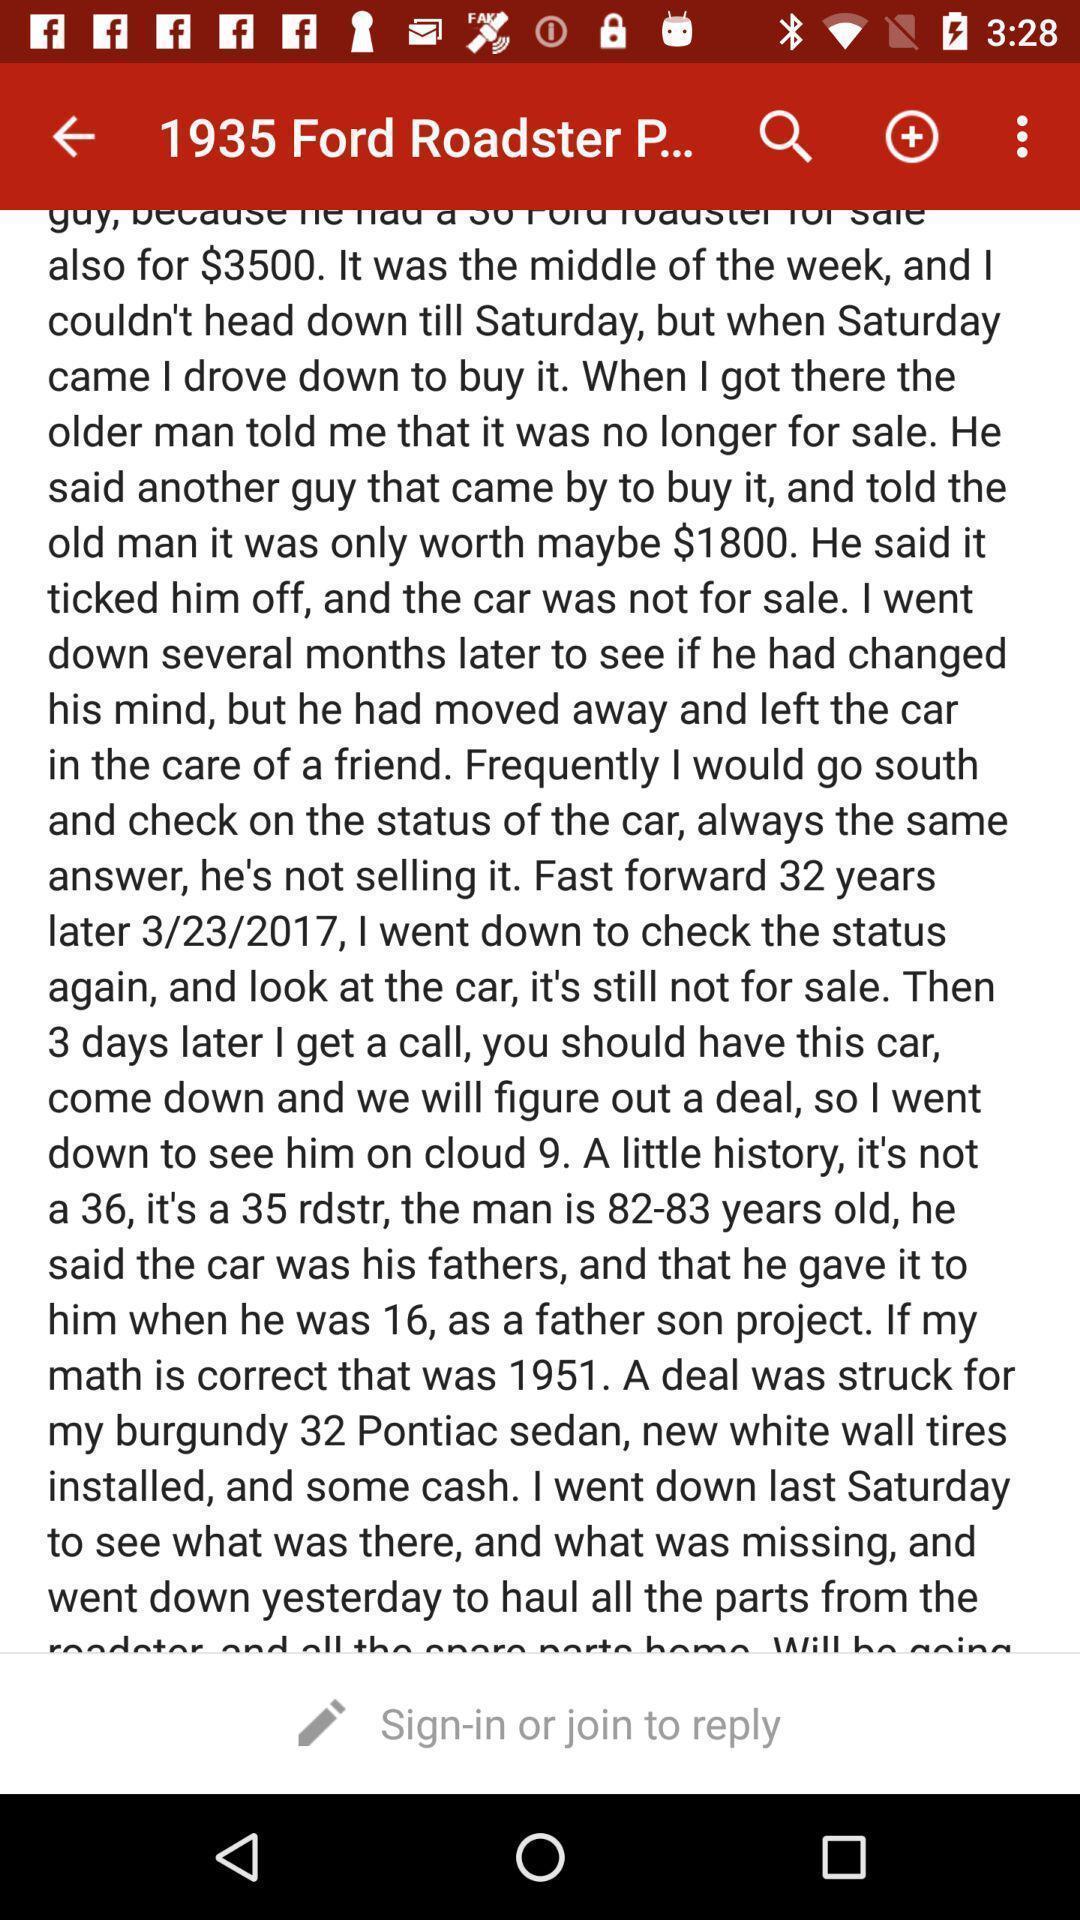Describe the visual elements of this screenshot. Page displays to sign in to reply in application. 